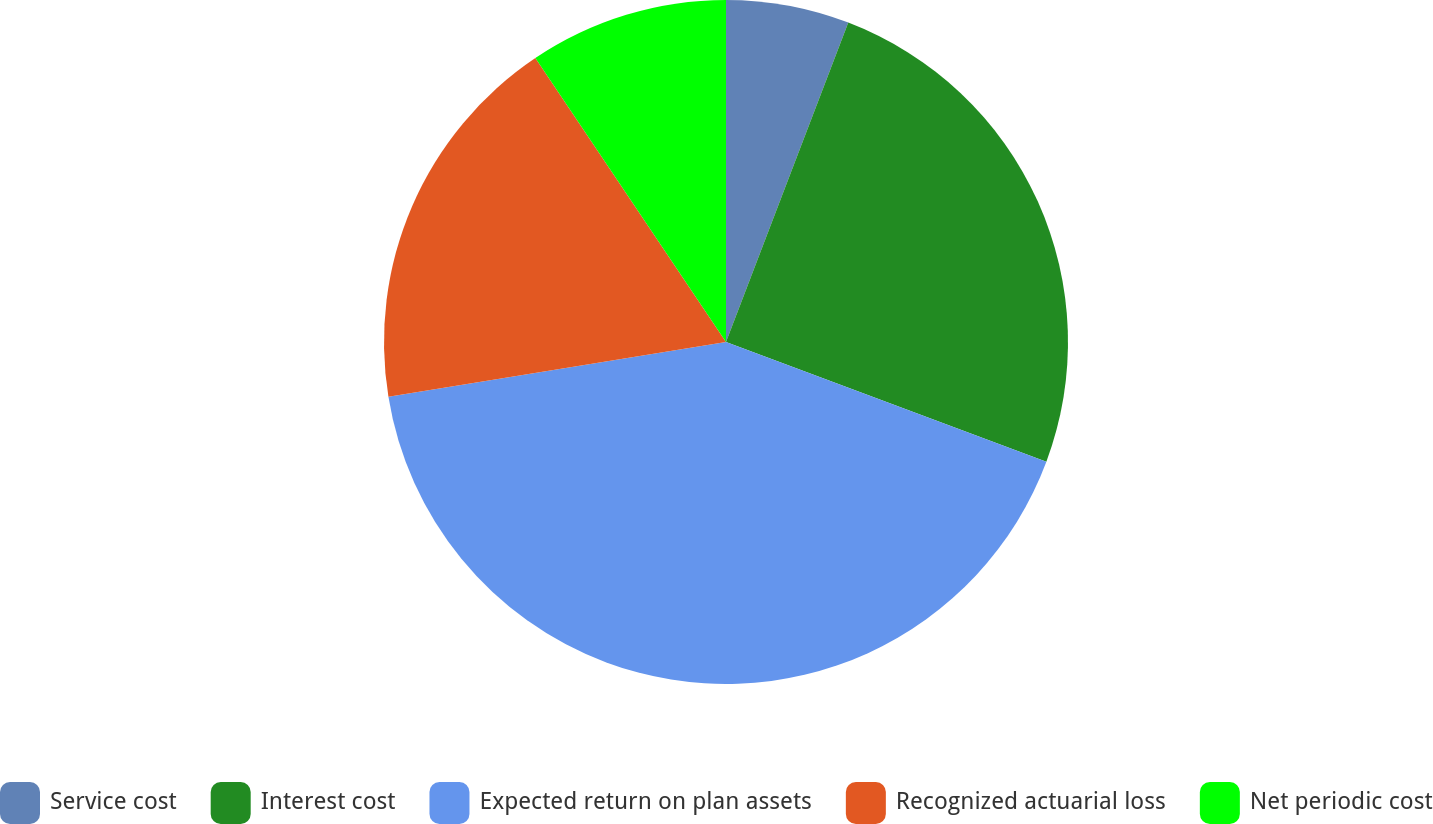Convert chart. <chart><loc_0><loc_0><loc_500><loc_500><pie_chart><fcel>Service cost<fcel>Interest cost<fcel>Expected return on plan assets<fcel>Recognized actuarial loss<fcel>Net periodic cost<nl><fcel>5.82%<fcel>24.87%<fcel>41.75%<fcel>18.15%<fcel>9.41%<nl></chart> 